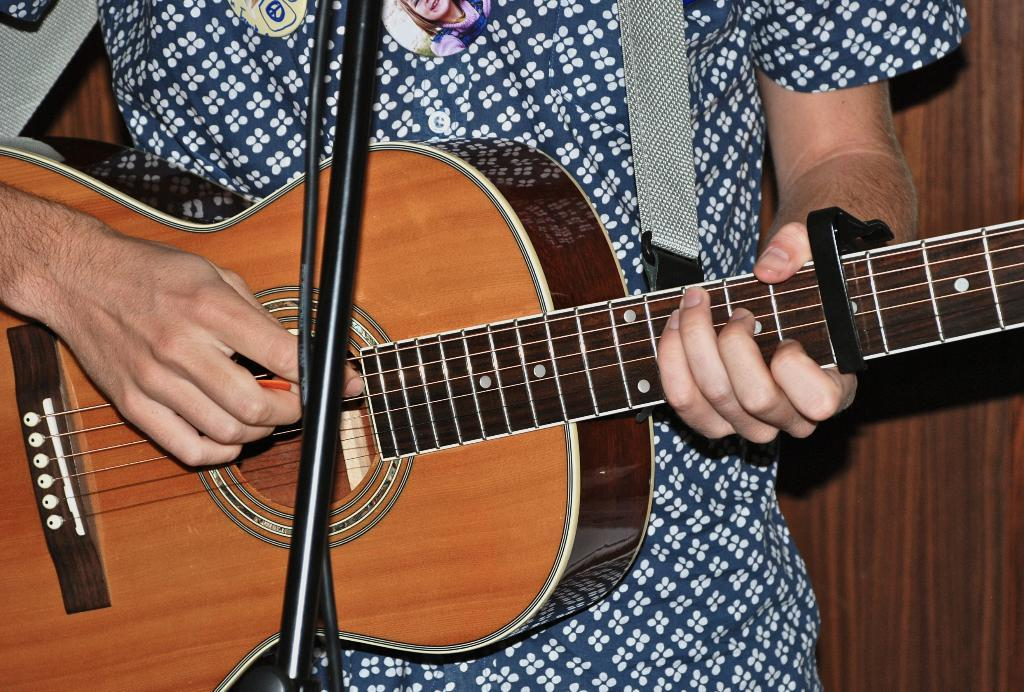What is the main subject of the image? The main subject of the image is a man. What is the man doing in the image? The man is playing a guitar in the image. What type of skate is the man using to play the guitar in the image? There is no skate present in the image; the man is playing a guitar without any additional equipment. 